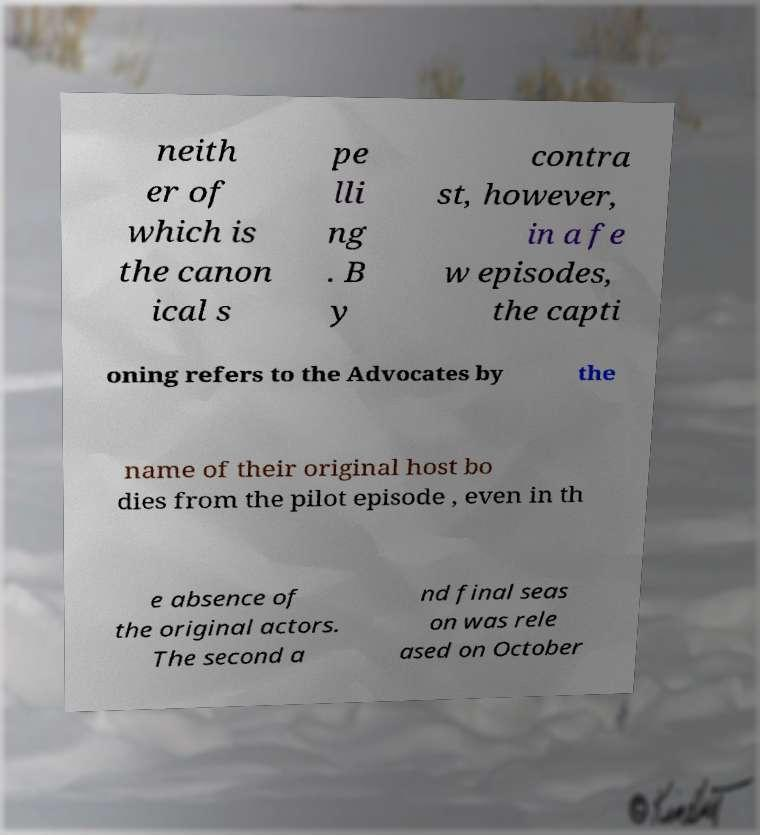Could you assist in decoding the text presented in this image and type it out clearly? neith er of which is the canon ical s pe lli ng . B y contra st, however, in a fe w episodes, the capti oning refers to the Advocates by the name of their original host bo dies from the pilot episode , even in th e absence of the original actors. The second a nd final seas on was rele ased on October 